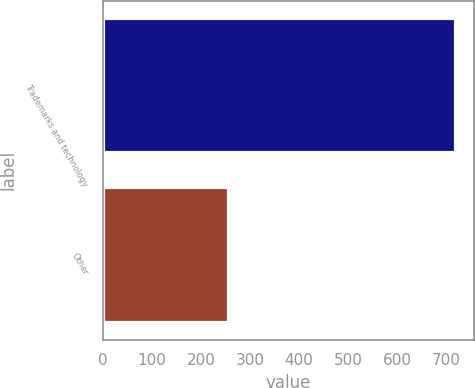Convert chart. <chart><loc_0><loc_0><loc_500><loc_500><bar_chart><fcel>Trademarks and technology<fcel>Other<nl><fcel>720<fcel>258<nl></chart> 